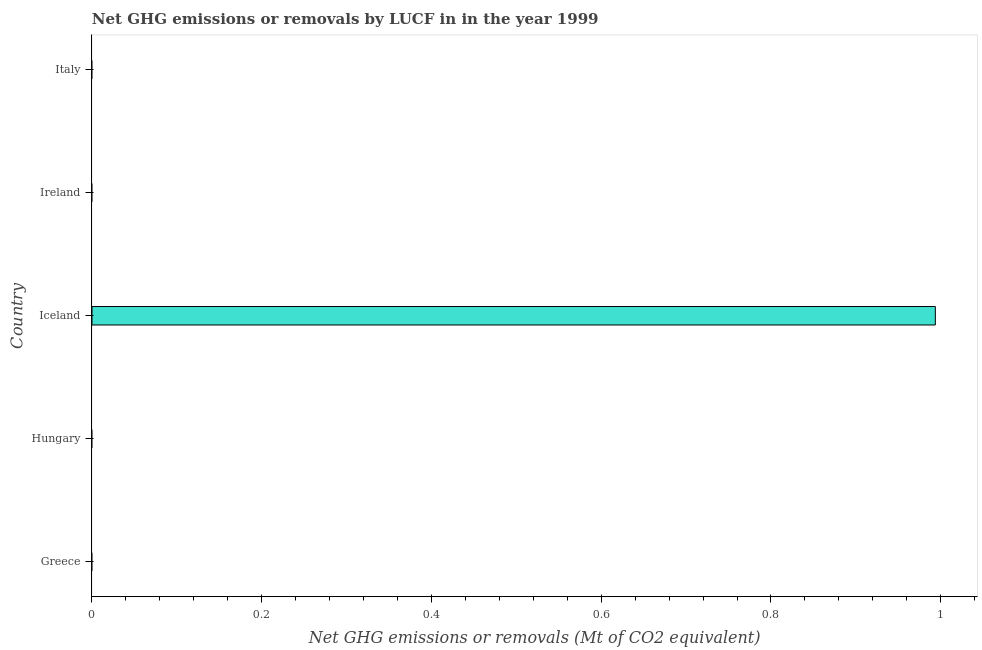What is the title of the graph?
Provide a succinct answer. Net GHG emissions or removals by LUCF in in the year 1999. What is the label or title of the X-axis?
Offer a very short reply. Net GHG emissions or removals (Mt of CO2 equivalent). What is the label or title of the Y-axis?
Provide a succinct answer. Country. What is the ghg net emissions or removals in Iceland?
Offer a very short reply. 0.99. Across all countries, what is the maximum ghg net emissions or removals?
Your response must be concise. 0.99. In which country was the ghg net emissions or removals maximum?
Give a very brief answer. Iceland. What is the sum of the ghg net emissions or removals?
Keep it short and to the point. 0.99. What is the average ghg net emissions or removals per country?
Give a very brief answer. 0.2. In how many countries, is the ghg net emissions or removals greater than 0.32 Mt?
Your answer should be compact. 1. How many countries are there in the graph?
Offer a terse response. 5. What is the difference between two consecutive major ticks on the X-axis?
Give a very brief answer. 0.2. Are the values on the major ticks of X-axis written in scientific E-notation?
Provide a succinct answer. No. What is the Net GHG emissions or removals (Mt of CO2 equivalent) of Greece?
Ensure brevity in your answer.  0. What is the Net GHG emissions or removals (Mt of CO2 equivalent) of Iceland?
Keep it short and to the point. 0.99. What is the Net GHG emissions or removals (Mt of CO2 equivalent) in Italy?
Your response must be concise. 0. 